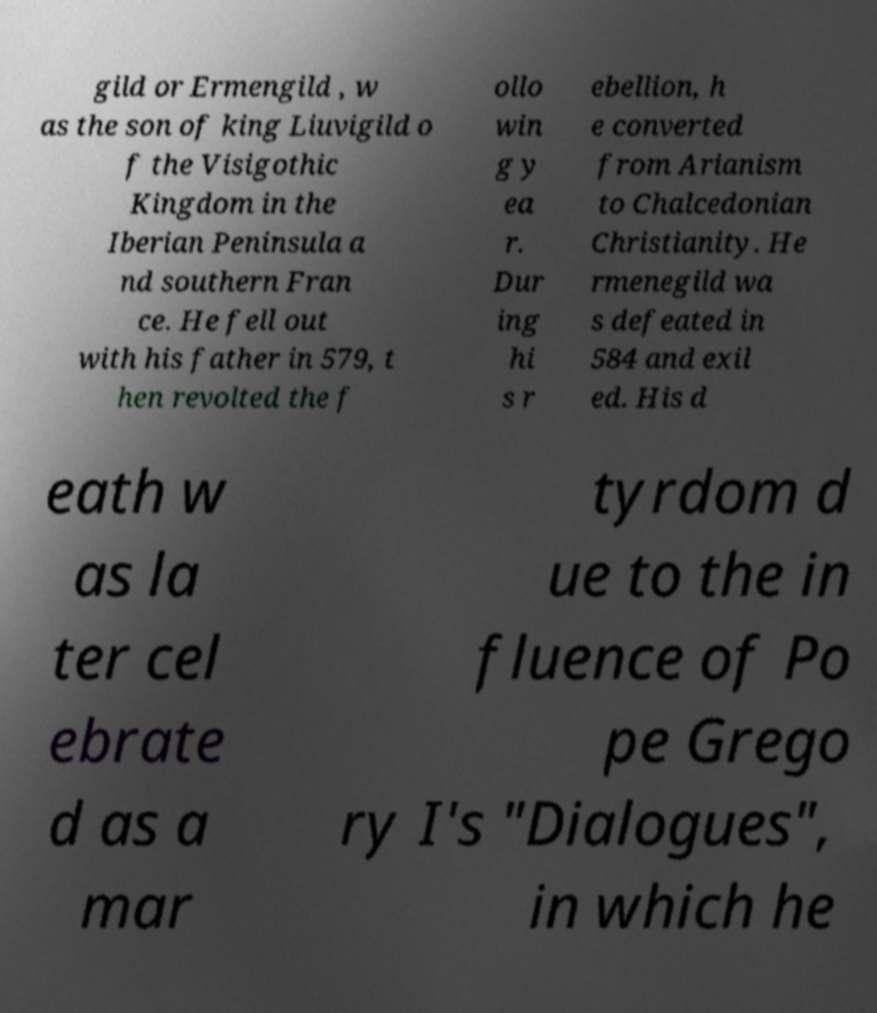There's text embedded in this image that I need extracted. Can you transcribe it verbatim? gild or Ermengild , w as the son of king Liuvigild o f the Visigothic Kingdom in the Iberian Peninsula a nd southern Fran ce. He fell out with his father in 579, t hen revolted the f ollo win g y ea r. Dur ing hi s r ebellion, h e converted from Arianism to Chalcedonian Christianity. He rmenegild wa s defeated in 584 and exil ed. His d eath w as la ter cel ebrate d as a mar tyrdom d ue to the in fluence of Po pe Grego ry I's "Dialogues", in which he 